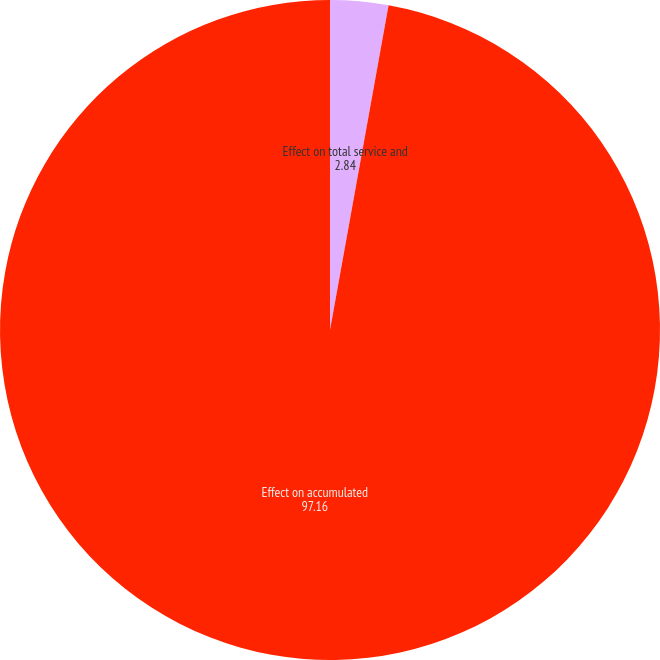Convert chart. <chart><loc_0><loc_0><loc_500><loc_500><pie_chart><fcel>Effect on total service and<fcel>Effect on accumulated<nl><fcel>2.84%<fcel>97.16%<nl></chart> 